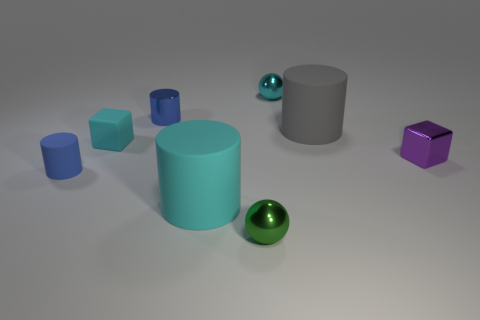Subtract all gray cylinders. How many cylinders are left? 3 Subtract all balls. How many objects are left? 6 Subtract 1 cubes. How many cubes are left? 1 Subtract all purple cubes. Subtract all red cylinders. How many cubes are left? 1 Subtract all yellow cubes. How many green spheres are left? 1 Subtract all small green shiny balls. Subtract all cubes. How many objects are left? 5 Add 6 blue matte cylinders. How many blue matte cylinders are left? 7 Add 2 tiny metal balls. How many tiny metal balls exist? 4 Add 2 tiny cyan objects. How many objects exist? 10 Subtract all cyan matte cylinders. How many cylinders are left? 3 